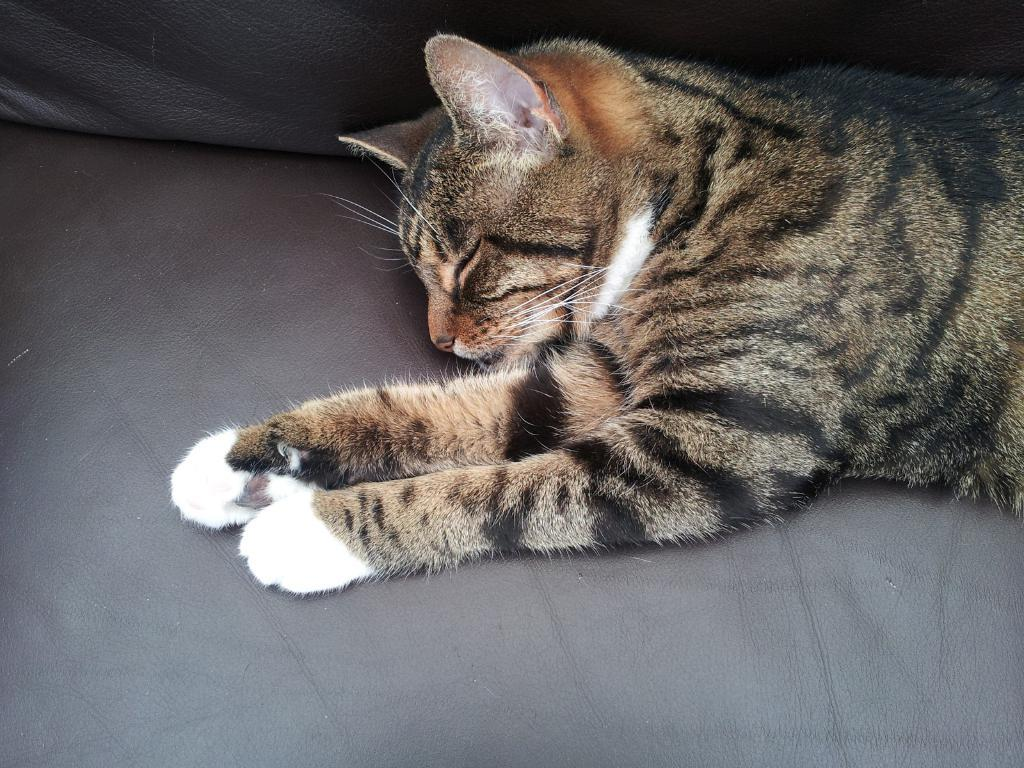What type of animal is present in the image? There is a cat in the image. Where is the cat located in the image? The cat is lying on a couch. What is the cat doing in the image? The cat is sleeping. What type of arch can be seen in the image? There is no arch present in the image; it features a cat lying on a couch. 